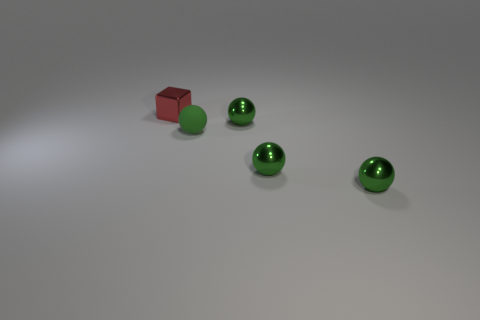Subtract all small rubber balls. How many balls are left? 3 Add 2 red cubes. How many objects exist? 7 Subtract 1 green spheres. How many objects are left? 4 Subtract all balls. How many objects are left? 1 Subtract 1 blocks. How many blocks are left? 0 Subtract all brown balls. Subtract all purple blocks. How many balls are left? 4 Subtract all big blue rubber cylinders. Subtract all small rubber balls. How many objects are left? 4 Add 1 tiny green objects. How many tiny green objects are left? 5 Add 5 green metal things. How many green metal things exist? 8 